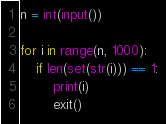Convert code to text. <code><loc_0><loc_0><loc_500><loc_500><_Python_>n = int(input())

for i in range(n, 1000):
    if len(set(str(i))) == 1:
        print(i)
        exit()</code> 